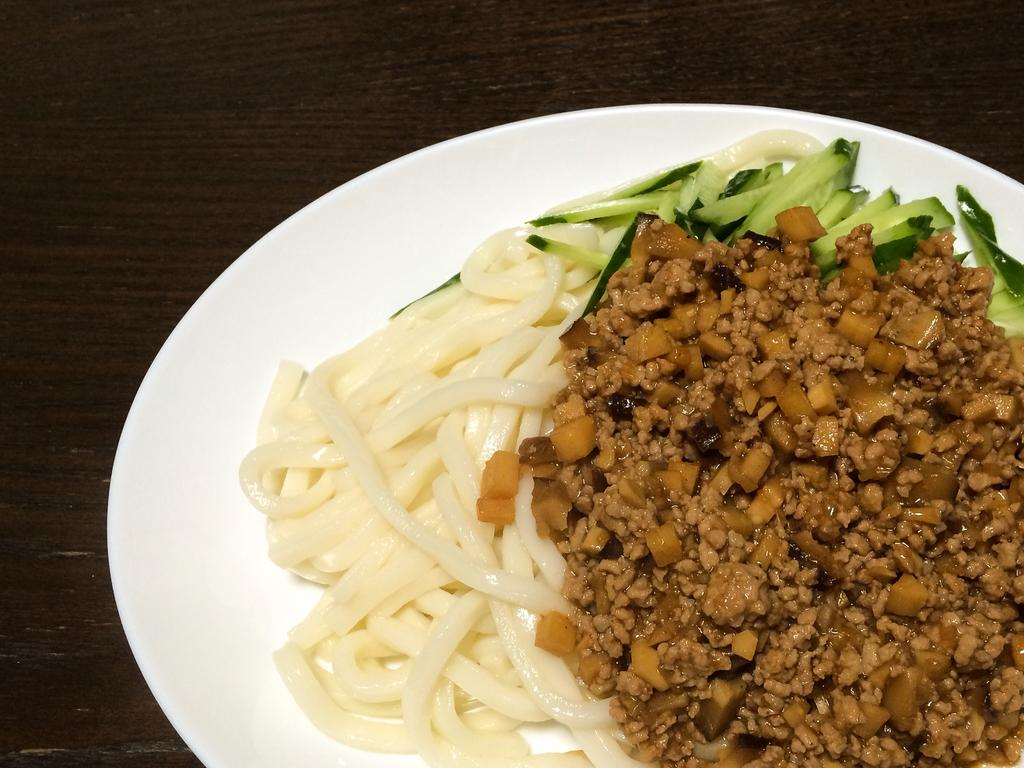What is the color of the platter in the image? The platter in the image is white. What is on the platter? The platter contains noodles and other food items. Where is the platter placed? The platter is placed on a wooden table. Are there any bananas visible on the ground in the image? There is no ground visible in the image, and no bananas are present. 